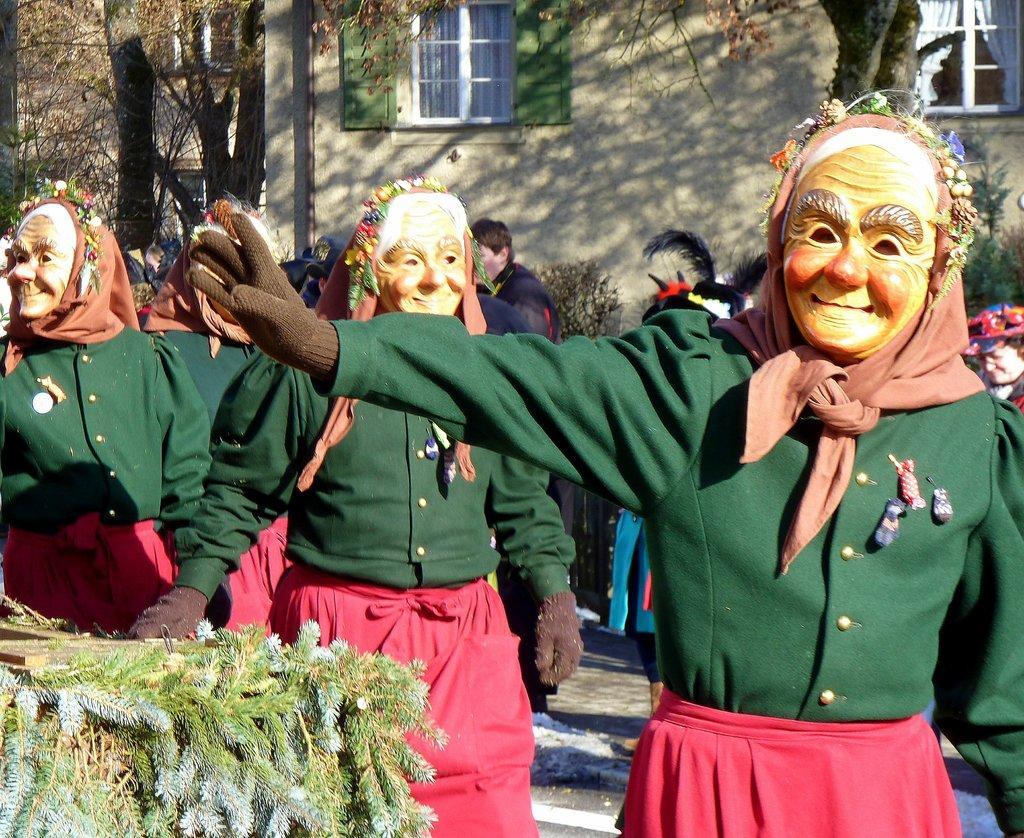How would you summarize this image in a sentence or two? In the foreground of the picture there are people wearing green dresses and masks. On the left there are plants. In the background there are people, plants, trees, windows and building. 